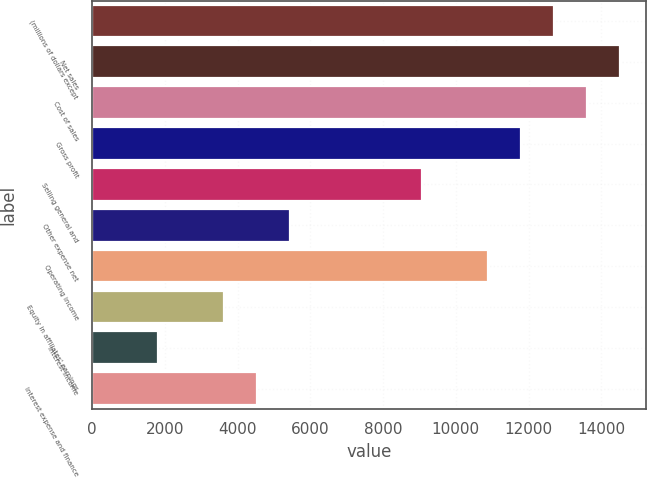<chart> <loc_0><loc_0><loc_500><loc_500><bar_chart><fcel>(millions of dollars except<fcel>Net sales<fcel>Cost of sales<fcel>Gross profit<fcel>Selling general and<fcel>Other expense net<fcel>Operating income<fcel>Equity in affiliates' earnings<fcel>Interest income<fcel>Interest expense and finance<nl><fcel>12698.2<fcel>14511.9<fcel>13605.1<fcel>11791.4<fcel>9070.96<fcel>5443.68<fcel>10884.6<fcel>3630.04<fcel>1816.4<fcel>4536.86<nl></chart> 